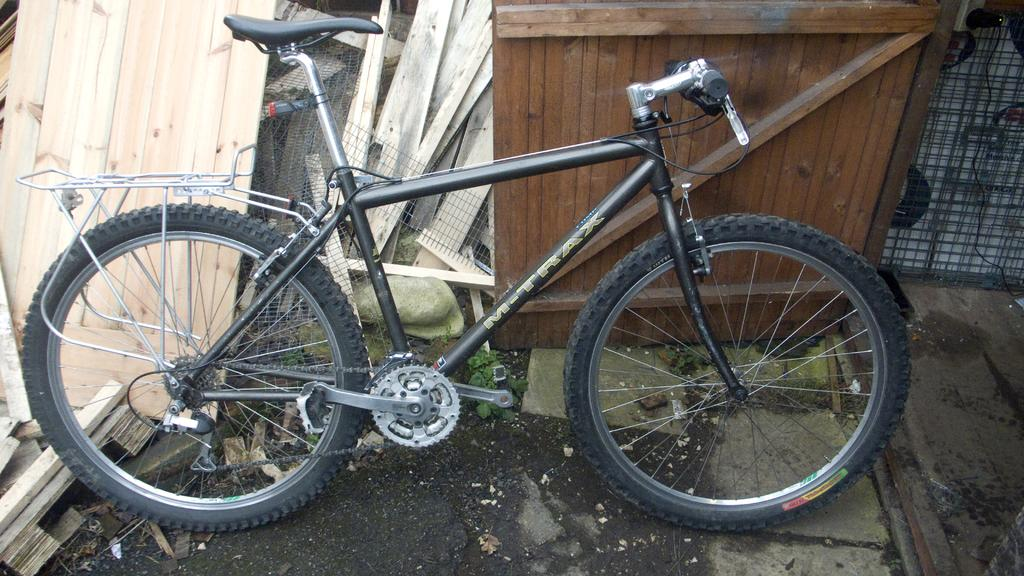What is the main object in the image? There is a bicycle in the image. What type of material is present in the image? There is mesh and cable wire in the image. What other objects can be seen in the image? There are wooden sheets in the image. What type of sugar is being used to sweeten the nation in the image? There is no mention of sugar or a nation in the image; it features a bicycle, mesh, cable wire, and wooden sheets. 